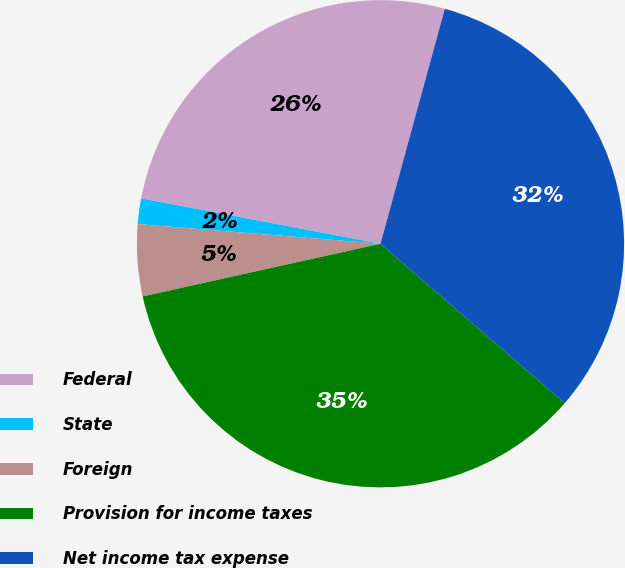Convert chart. <chart><loc_0><loc_0><loc_500><loc_500><pie_chart><fcel>Federal<fcel>State<fcel>Foreign<fcel>Provision for income taxes<fcel>Net income tax expense<nl><fcel>26.27%<fcel>1.69%<fcel>4.76%<fcel>35.17%<fcel>32.1%<nl></chart> 